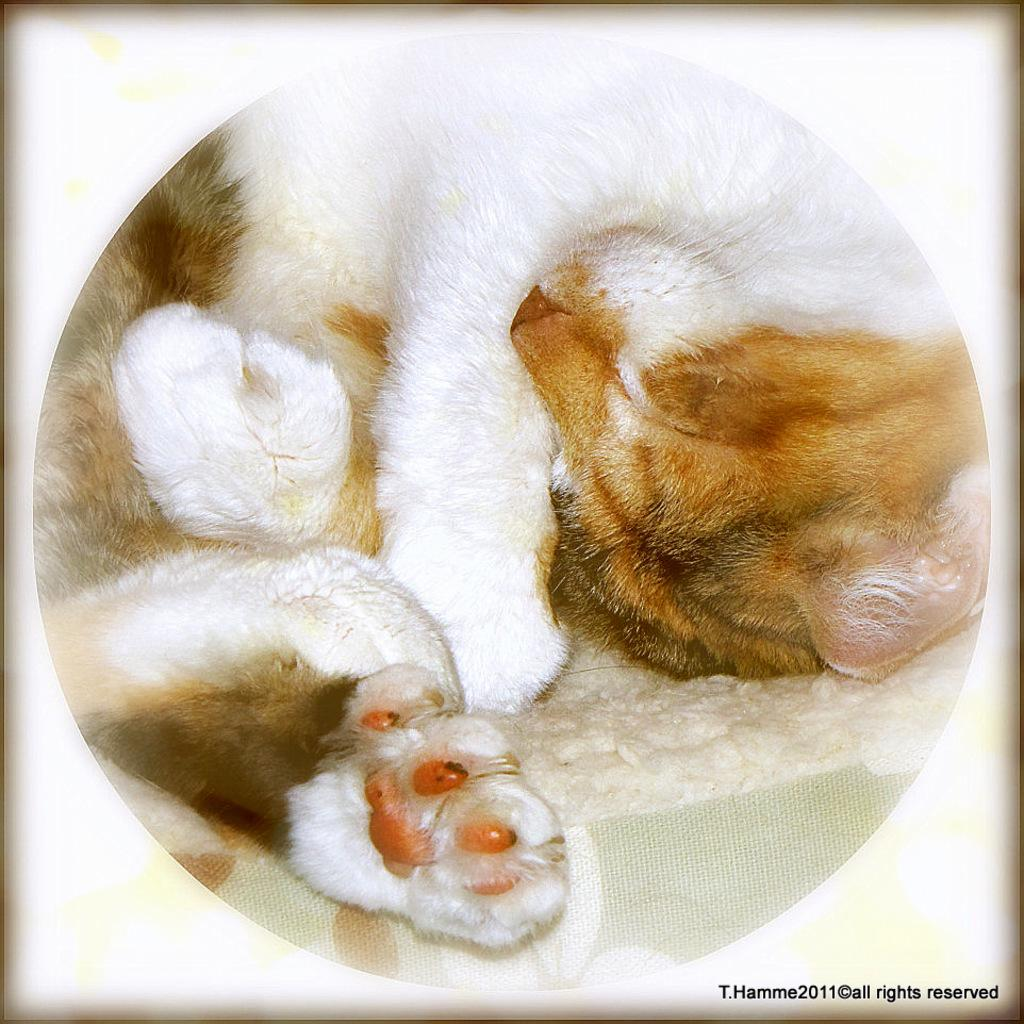What animal can be seen in the picture? There is a dog in the picture. What is the dog doing in the image? The dog is laying over a place. Can you tell if the image has been altered or edited in any way? Yes, the image appears to be edited. What type of bomb can be seen in the image? There is no bomb present in the image; it features a dog laying over a place. What color are the trousers worn by the dog in the image? Dogs do not wear trousers, and there is no clothing visible in the image. 